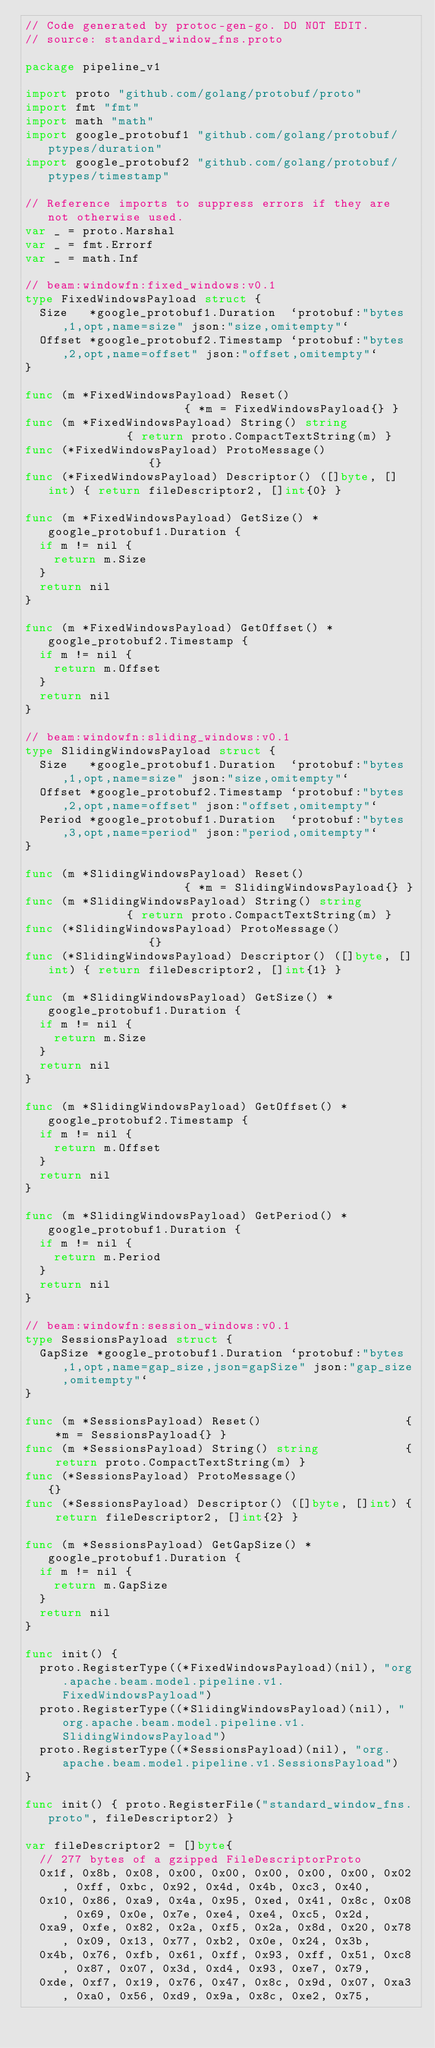<code> <loc_0><loc_0><loc_500><loc_500><_Go_>// Code generated by protoc-gen-go. DO NOT EDIT.
// source: standard_window_fns.proto

package pipeline_v1

import proto "github.com/golang/protobuf/proto"
import fmt "fmt"
import math "math"
import google_protobuf1 "github.com/golang/protobuf/ptypes/duration"
import google_protobuf2 "github.com/golang/protobuf/ptypes/timestamp"

// Reference imports to suppress errors if they are not otherwise used.
var _ = proto.Marshal
var _ = fmt.Errorf
var _ = math.Inf

// beam:windowfn:fixed_windows:v0.1
type FixedWindowsPayload struct {
	Size   *google_protobuf1.Duration  `protobuf:"bytes,1,opt,name=size" json:"size,omitempty"`
	Offset *google_protobuf2.Timestamp `protobuf:"bytes,2,opt,name=offset" json:"offset,omitempty"`
}

func (m *FixedWindowsPayload) Reset()                    { *m = FixedWindowsPayload{} }
func (m *FixedWindowsPayload) String() string            { return proto.CompactTextString(m) }
func (*FixedWindowsPayload) ProtoMessage()               {}
func (*FixedWindowsPayload) Descriptor() ([]byte, []int) { return fileDescriptor2, []int{0} }

func (m *FixedWindowsPayload) GetSize() *google_protobuf1.Duration {
	if m != nil {
		return m.Size
	}
	return nil
}

func (m *FixedWindowsPayload) GetOffset() *google_protobuf2.Timestamp {
	if m != nil {
		return m.Offset
	}
	return nil
}

// beam:windowfn:sliding_windows:v0.1
type SlidingWindowsPayload struct {
	Size   *google_protobuf1.Duration  `protobuf:"bytes,1,opt,name=size" json:"size,omitempty"`
	Offset *google_protobuf2.Timestamp `protobuf:"bytes,2,opt,name=offset" json:"offset,omitempty"`
	Period *google_protobuf1.Duration  `protobuf:"bytes,3,opt,name=period" json:"period,omitempty"`
}

func (m *SlidingWindowsPayload) Reset()                    { *m = SlidingWindowsPayload{} }
func (m *SlidingWindowsPayload) String() string            { return proto.CompactTextString(m) }
func (*SlidingWindowsPayload) ProtoMessage()               {}
func (*SlidingWindowsPayload) Descriptor() ([]byte, []int) { return fileDescriptor2, []int{1} }

func (m *SlidingWindowsPayload) GetSize() *google_protobuf1.Duration {
	if m != nil {
		return m.Size
	}
	return nil
}

func (m *SlidingWindowsPayload) GetOffset() *google_protobuf2.Timestamp {
	if m != nil {
		return m.Offset
	}
	return nil
}

func (m *SlidingWindowsPayload) GetPeriod() *google_protobuf1.Duration {
	if m != nil {
		return m.Period
	}
	return nil
}

// beam:windowfn:session_windows:v0.1
type SessionsPayload struct {
	GapSize *google_protobuf1.Duration `protobuf:"bytes,1,opt,name=gap_size,json=gapSize" json:"gap_size,omitempty"`
}

func (m *SessionsPayload) Reset()                    { *m = SessionsPayload{} }
func (m *SessionsPayload) String() string            { return proto.CompactTextString(m) }
func (*SessionsPayload) ProtoMessage()               {}
func (*SessionsPayload) Descriptor() ([]byte, []int) { return fileDescriptor2, []int{2} }

func (m *SessionsPayload) GetGapSize() *google_protobuf1.Duration {
	if m != nil {
		return m.GapSize
	}
	return nil
}

func init() {
	proto.RegisterType((*FixedWindowsPayload)(nil), "org.apache.beam.model.pipeline.v1.FixedWindowsPayload")
	proto.RegisterType((*SlidingWindowsPayload)(nil), "org.apache.beam.model.pipeline.v1.SlidingWindowsPayload")
	proto.RegisterType((*SessionsPayload)(nil), "org.apache.beam.model.pipeline.v1.SessionsPayload")
}

func init() { proto.RegisterFile("standard_window_fns.proto", fileDescriptor2) }

var fileDescriptor2 = []byte{
	// 277 bytes of a gzipped FileDescriptorProto
	0x1f, 0x8b, 0x08, 0x00, 0x00, 0x00, 0x00, 0x00, 0x02, 0xff, 0xbc, 0x92, 0x4d, 0x4b, 0xc3, 0x40,
	0x10, 0x86, 0xa9, 0x4a, 0x95, 0xed, 0x41, 0x8c, 0x08, 0x69, 0x0e, 0x7e, 0xe4, 0xe4, 0xc5, 0x2d,
	0xa9, 0xfe, 0x82, 0x2a, 0xf5, 0x2a, 0x8d, 0x20, 0x78, 0x09, 0x13, 0x77, 0xb2, 0x0e, 0x24, 0x3b,
	0x4b, 0x76, 0xfb, 0x61, 0xff, 0x93, 0xff, 0x51, 0xc8, 0x87, 0x07, 0x3d, 0xd4, 0x93, 0xe7, 0x79,
	0xde, 0xf7, 0x19, 0x76, 0x47, 0x8c, 0x9d, 0x07, 0xa3, 0xa0, 0x56, 0xd9, 0x9a, 0x8c, 0xe2, 0x75,</code> 